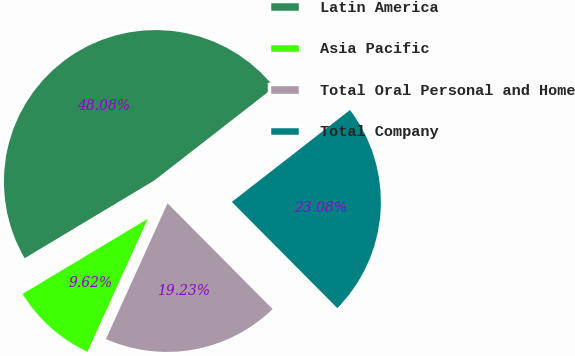Convert chart to OTSL. <chart><loc_0><loc_0><loc_500><loc_500><pie_chart><fcel>Latin America<fcel>Asia Pacific<fcel>Total Oral Personal and Home<fcel>Total Company<nl><fcel>48.08%<fcel>9.62%<fcel>19.23%<fcel>23.08%<nl></chart> 